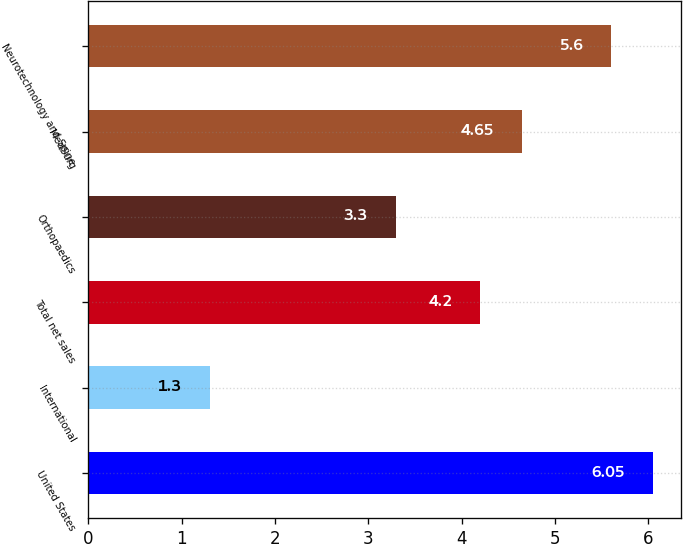<chart> <loc_0><loc_0><loc_500><loc_500><bar_chart><fcel>United States<fcel>International<fcel>Total net sales<fcel>Orthopaedics<fcel>MedSurg<fcel>Neurotechnology and Spine<nl><fcel>6.05<fcel>1.3<fcel>4.2<fcel>3.3<fcel>4.65<fcel>5.6<nl></chart> 